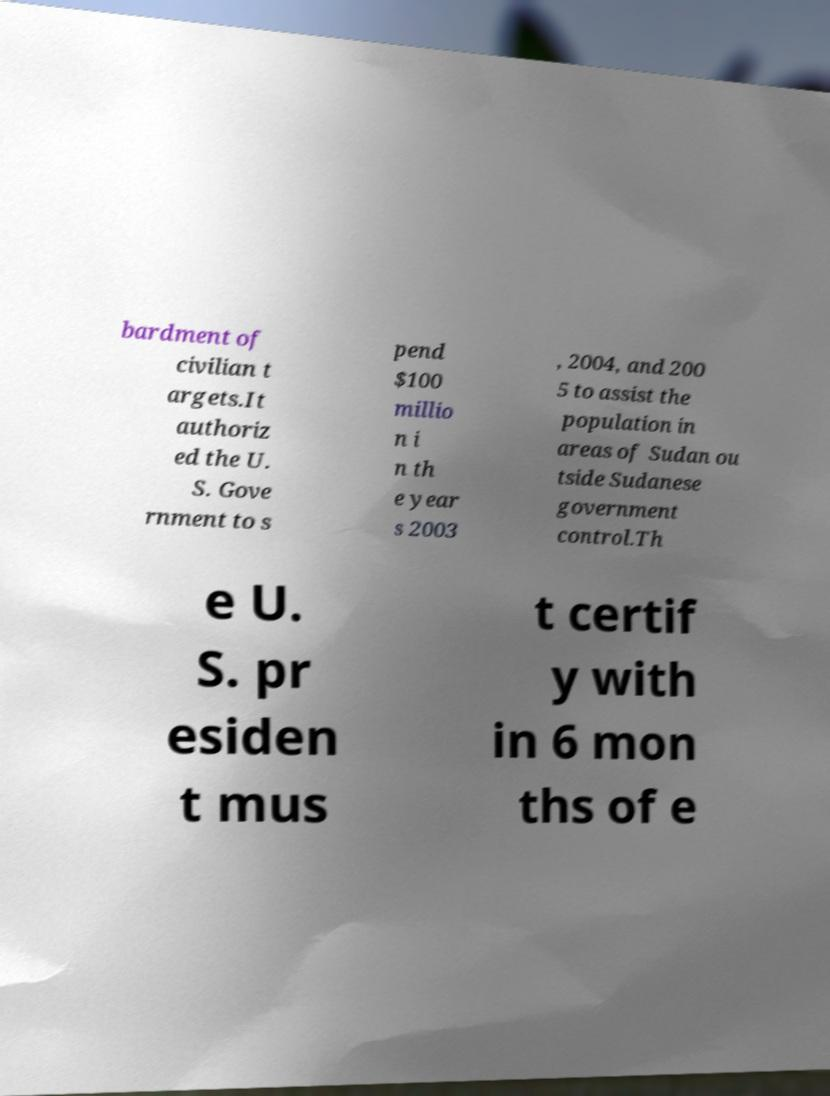There's text embedded in this image that I need extracted. Can you transcribe it verbatim? bardment of civilian t argets.It authoriz ed the U. S. Gove rnment to s pend $100 millio n i n th e year s 2003 , 2004, and 200 5 to assist the population in areas of Sudan ou tside Sudanese government control.Th e U. S. pr esiden t mus t certif y with in 6 mon ths of e 